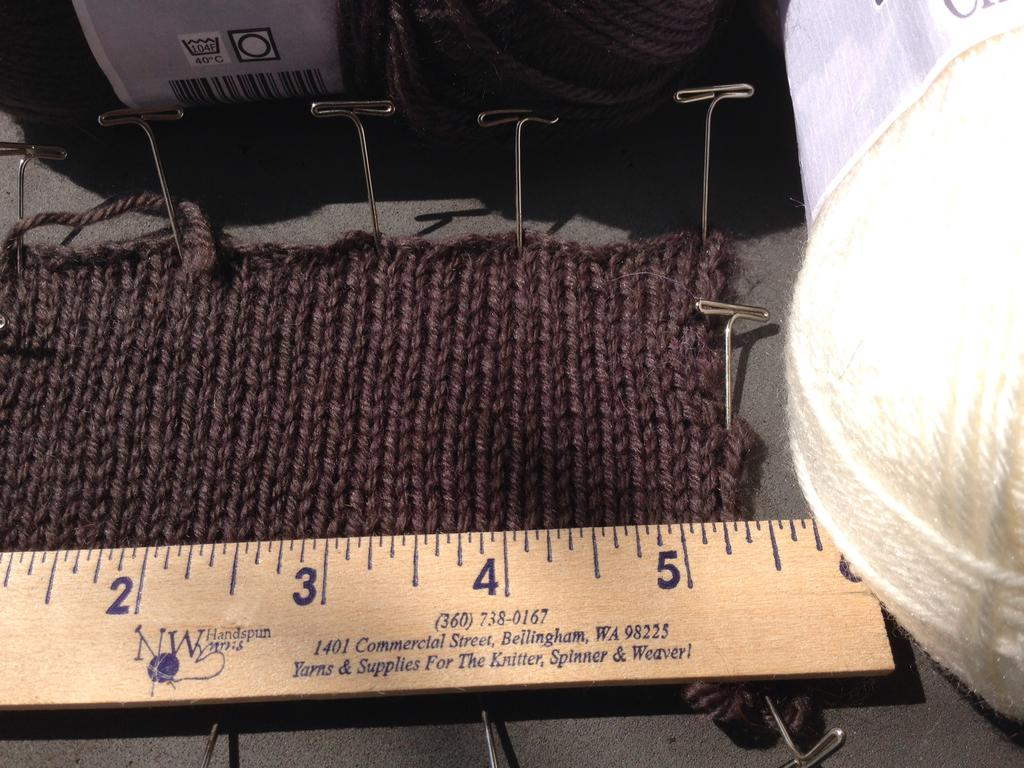<image>
Offer a succinct explanation of the picture presented. A NW Handspun Yarns ruler next to some yarn. 